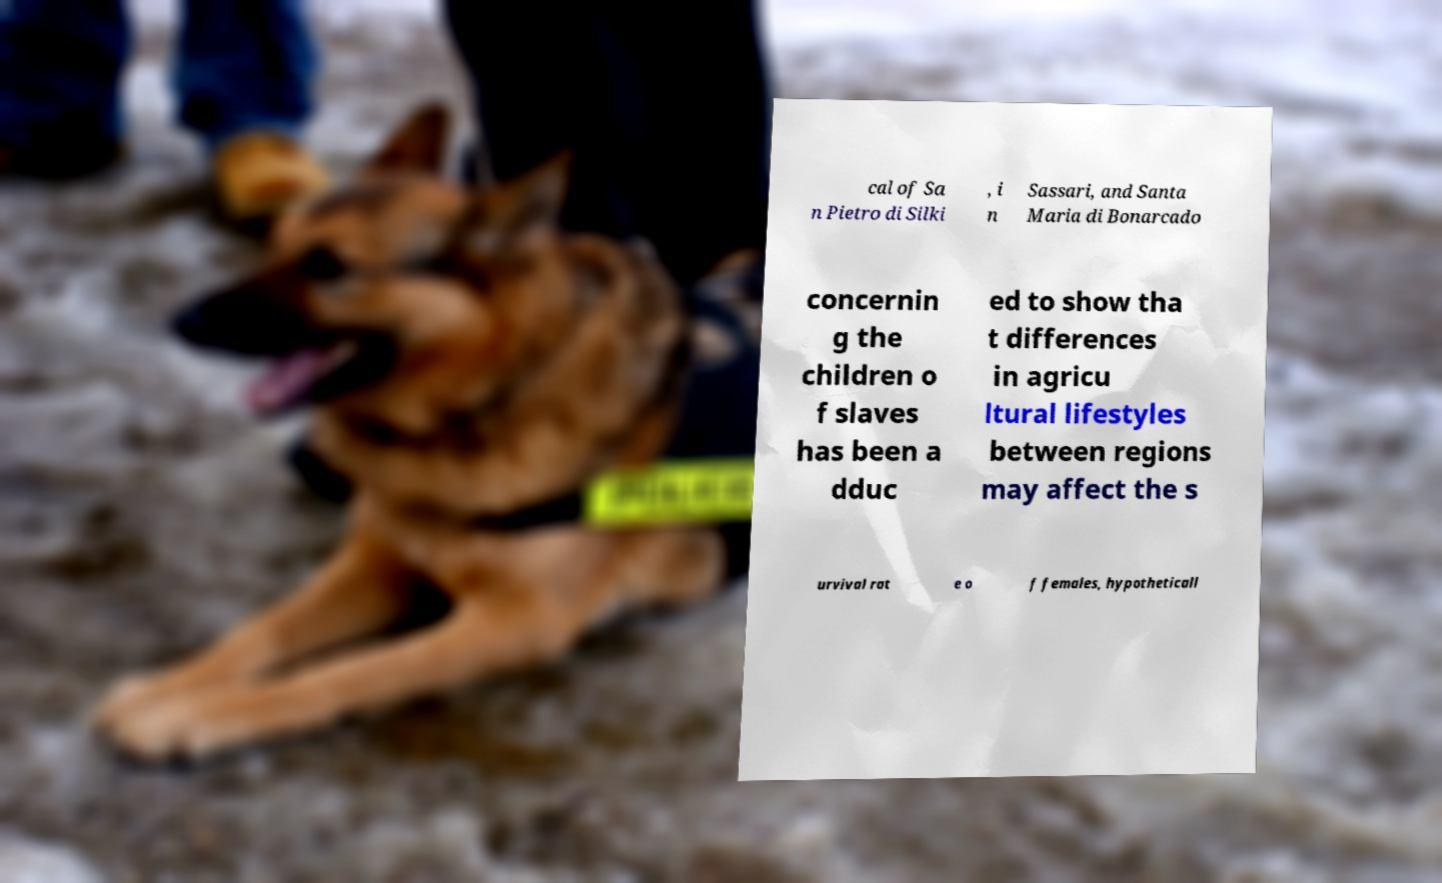There's text embedded in this image that I need extracted. Can you transcribe it verbatim? cal of Sa n Pietro di Silki , i n Sassari, and Santa Maria di Bonarcado concernin g the children o f slaves has been a dduc ed to show tha t differences in agricu ltural lifestyles between regions may affect the s urvival rat e o f females, hypotheticall 